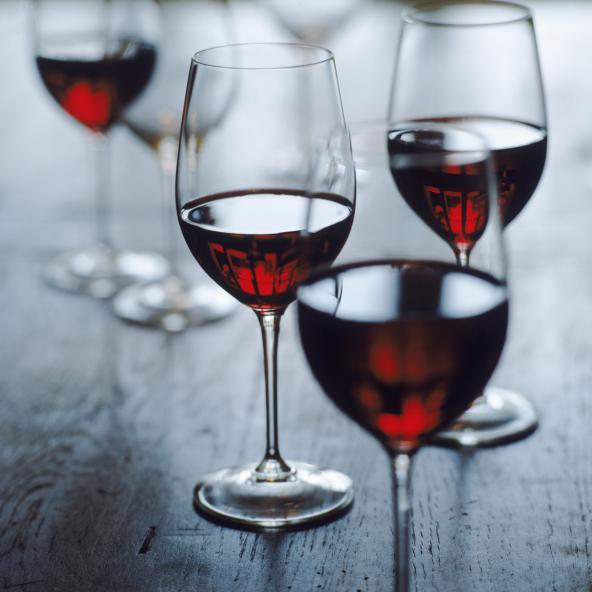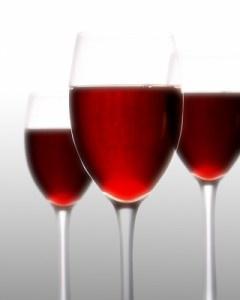The first image is the image on the left, the second image is the image on the right. For the images displayed, is the sentence "The image on the right has three glasses of red wine." factually correct? Answer yes or no. Yes. The first image is the image on the left, the second image is the image on the right. Analyze the images presented: Is the assertion "Left image shows exactly three half-full wine glasses arranged in a row." valid? Answer yes or no. No. 